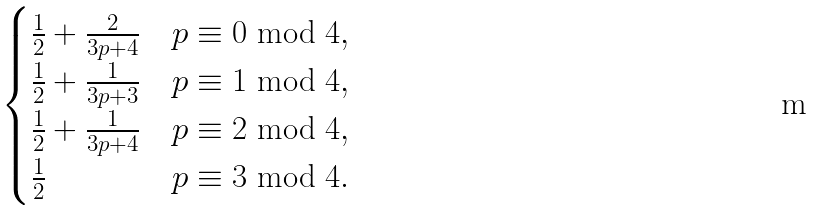Convert formula to latex. <formula><loc_0><loc_0><loc_500><loc_500>\begin{cases} \frac { 1 } { 2 } + \frac { 2 } { 3 p + 4 } & p \equiv 0 \bmod 4 , \\ \frac { 1 } { 2 } + \frac { 1 } { 3 p + 3 } & p \equiv 1 \bmod 4 , \\ \frac { 1 } { 2 } + \frac { 1 } { 3 p + 4 } & p \equiv 2 \bmod 4 , \\ \frac { 1 } { 2 } & p \equiv 3 \bmod 4 . \end{cases}</formula> 